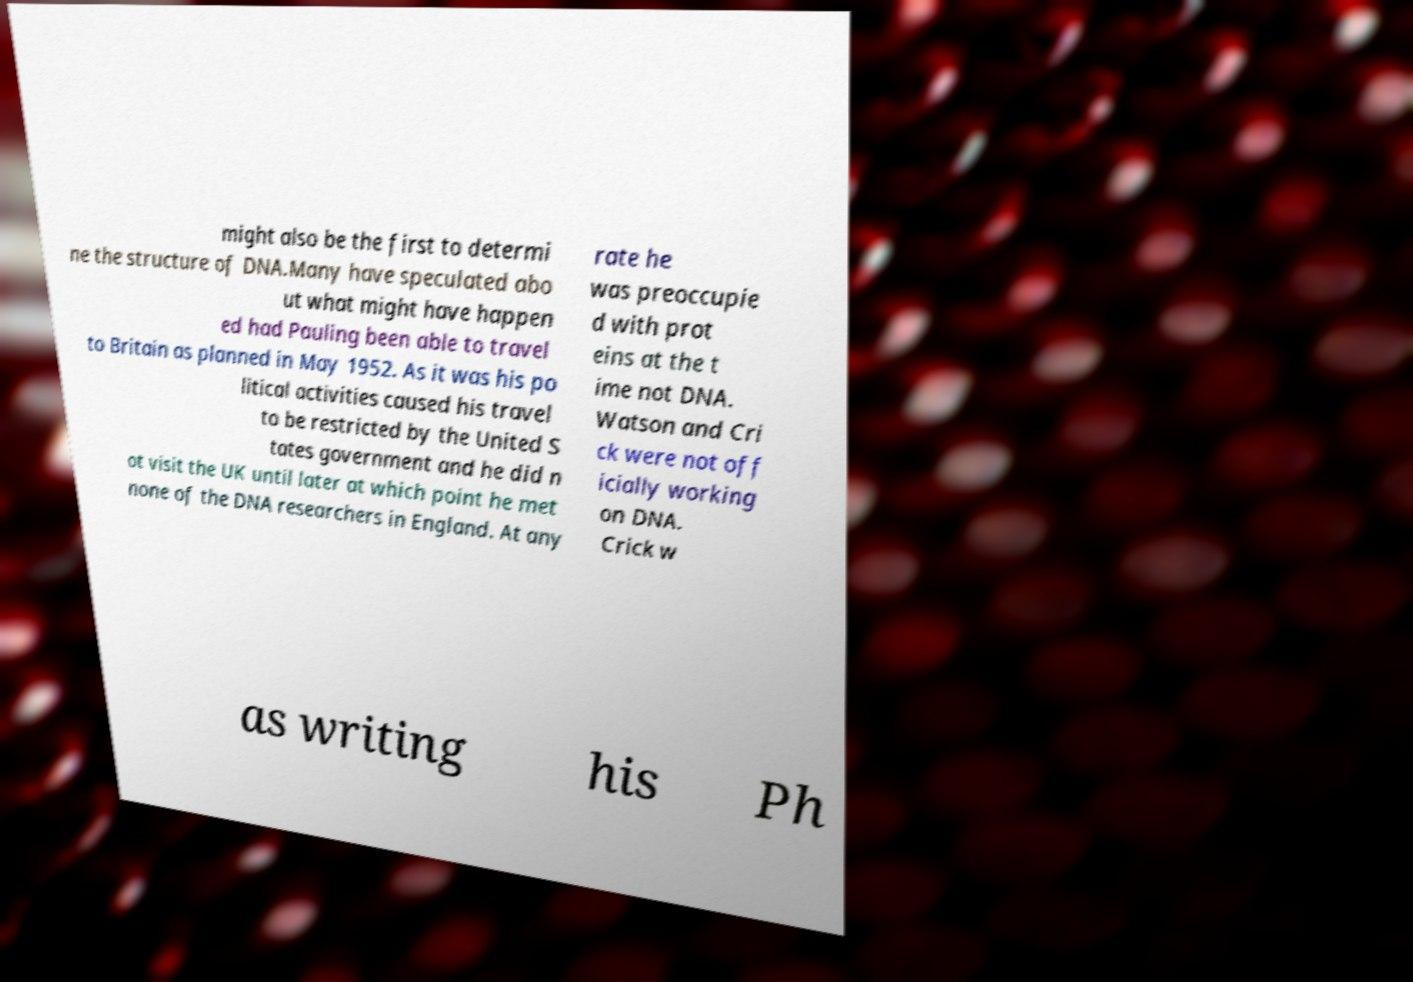Please identify and transcribe the text found in this image. might also be the first to determi ne the structure of DNA.Many have speculated abo ut what might have happen ed had Pauling been able to travel to Britain as planned in May 1952. As it was his po litical activities caused his travel to be restricted by the United S tates government and he did n ot visit the UK until later at which point he met none of the DNA researchers in England. At any rate he was preoccupie d with prot eins at the t ime not DNA. Watson and Cri ck were not off icially working on DNA. Crick w as writing his Ph 